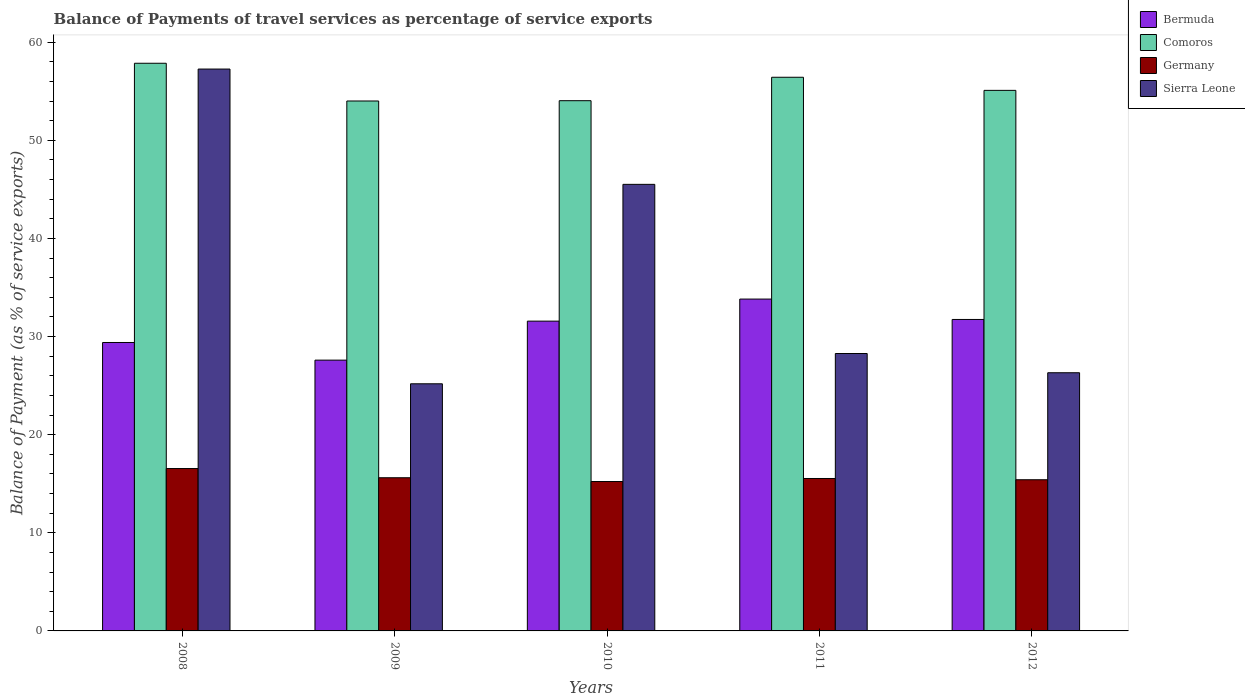How many different coloured bars are there?
Ensure brevity in your answer.  4. How many bars are there on the 3rd tick from the left?
Provide a succinct answer. 4. How many bars are there on the 3rd tick from the right?
Provide a succinct answer. 4. What is the balance of payments of travel services in Sierra Leone in 2012?
Ensure brevity in your answer.  26.31. Across all years, what is the maximum balance of payments of travel services in Germany?
Make the answer very short. 16.55. Across all years, what is the minimum balance of payments of travel services in Germany?
Keep it short and to the point. 15.23. In which year was the balance of payments of travel services in Bermuda maximum?
Provide a short and direct response. 2011. What is the total balance of payments of travel services in Bermuda in the graph?
Provide a succinct answer. 154.12. What is the difference between the balance of payments of travel services in Comoros in 2010 and that in 2012?
Your answer should be very brief. -1.05. What is the difference between the balance of payments of travel services in Comoros in 2010 and the balance of payments of travel services in Sierra Leone in 2012?
Your answer should be compact. 27.73. What is the average balance of payments of travel services in Germany per year?
Your answer should be very brief. 15.67. In the year 2011, what is the difference between the balance of payments of travel services in Comoros and balance of payments of travel services in Bermuda?
Give a very brief answer. 22.61. What is the ratio of the balance of payments of travel services in Germany in 2009 to that in 2010?
Offer a terse response. 1.03. What is the difference between the highest and the second highest balance of payments of travel services in Bermuda?
Offer a terse response. 2.08. What is the difference between the highest and the lowest balance of payments of travel services in Comoros?
Make the answer very short. 3.85. Is the sum of the balance of payments of travel services in Germany in 2008 and 2010 greater than the maximum balance of payments of travel services in Comoros across all years?
Offer a very short reply. No. What does the 3rd bar from the left in 2009 represents?
Keep it short and to the point. Germany. What does the 1st bar from the right in 2012 represents?
Your answer should be compact. Sierra Leone. Is it the case that in every year, the sum of the balance of payments of travel services in Bermuda and balance of payments of travel services in Sierra Leone is greater than the balance of payments of travel services in Comoros?
Offer a terse response. No. How many bars are there?
Offer a very short reply. 20. Are all the bars in the graph horizontal?
Keep it short and to the point. No. What is the difference between two consecutive major ticks on the Y-axis?
Make the answer very short. 10. Are the values on the major ticks of Y-axis written in scientific E-notation?
Make the answer very short. No. Where does the legend appear in the graph?
Provide a short and direct response. Top right. What is the title of the graph?
Provide a succinct answer. Balance of Payments of travel services as percentage of service exports. Does "Lao PDR" appear as one of the legend labels in the graph?
Ensure brevity in your answer.  No. What is the label or title of the X-axis?
Make the answer very short. Years. What is the label or title of the Y-axis?
Your response must be concise. Balance of Payment (as % of service exports). What is the Balance of Payment (as % of service exports) of Bermuda in 2008?
Your answer should be very brief. 29.39. What is the Balance of Payment (as % of service exports) in Comoros in 2008?
Ensure brevity in your answer.  57.85. What is the Balance of Payment (as % of service exports) in Germany in 2008?
Offer a very short reply. 16.55. What is the Balance of Payment (as % of service exports) of Sierra Leone in 2008?
Your response must be concise. 57.26. What is the Balance of Payment (as % of service exports) of Bermuda in 2009?
Your response must be concise. 27.6. What is the Balance of Payment (as % of service exports) of Comoros in 2009?
Your response must be concise. 54.01. What is the Balance of Payment (as % of service exports) in Germany in 2009?
Your answer should be very brief. 15.61. What is the Balance of Payment (as % of service exports) of Sierra Leone in 2009?
Make the answer very short. 25.19. What is the Balance of Payment (as % of service exports) of Bermuda in 2010?
Make the answer very short. 31.57. What is the Balance of Payment (as % of service exports) in Comoros in 2010?
Provide a short and direct response. 54.04. What is the Balance of Payment (as % of service exports) in Germany in 2010?
Your response must be concise. 15.23. What is the Balance of Payment (as % of service exports) in Sierra Leone in 2010?
Offer a terse response. 45.51. What is the Balance of Payment (as % of service exports) of Bermuda in 2011?
Keep it short and to the point. 33.82. What is the Balance of Payment (as % of service exports) of Comoros in 2011?
Ensure brevity in your answer.  56.42. What is the Balance of Payment (as % of service exports) of Germany in 2011?
Provide a short and direct response. 15.53. What is the Balance of Payment (as % of service exports) in Sierra Leone in 2011?
Your answer should be very brief. 28.27. What is the Balance of Payment (as % of service exports) in Bermuda in 2012?
Your answer should be compact. 31.74. What is the Balance of Payment (as % of service exports) in Comoros in 2012?
Make the answer very short. 55.09. What is the Balance of Payment (as % of service exports) of Germany in 2012?
Keep it short and to the point. 15.41. What is the Balance of Payment (as % of service exports) in Sierra Leone in 2012?
Ensure brevity in your answer.  26.31. Across all years, what is the maximum Balance of Payment (as % of service exports) of Bermuda?
Your answer should be very brief. 33.82. Across all years, what is the maximum Balance of Payment (as % of service exports) in Comoros?
Keep it short and to the point. 57.85. Across all years, what is the maximum Balance of Payment (as % of service exports) in Germany?
Give a very brief answer. 16.55. Across all years, what is the maximum Balance of Payment (as % of service exports) of Sierra Leone?
Offer a very short reply. 57.26. Across all years, what is the minimum Balance of Payment (as % of service exports) in Bermuda?
Keep it short and to the point. 27.6. Across all years, what is the minimum Balance of Payment (as % of service exports) in Comoros?
Keep it short and to the point. 54.01. Across all years, what is the minimum Balance of Payment (as % of service exports) of Germany?
Your response must be concise. 15.23. Across all years, what is the minimum Balance of Payment (as % of service exports) of Sierra Leone?
Your response must be concise. 25.19. What is the total Balance of Payment (as % of service exports) of Bermuda in the graph?
Your response must be concise. 154.12. What is the total Balance of Payment (as % of service exports) of Comoros in the graph?
Keep it short and to the point. 277.41. What is the total Balance of Payment (as % of service exports) in Germany in the graph?
Offer a terse response. 78.33. What is the total Balance of Payment (as % of service exports) in Sierra Leone in the graph?
Keep it short and to the point. 182.54. What is the difference between the Balance of Payment (as % of service exports) of Bermuda in 2008 and that in 2009?
Make the answer very short. 1.8. What is the difference between the Balance of Payment (as % of service exports) in Comoros in 2008 and that in 2009?
Your response must be concise. 3.85. What is the difference between the Balance of Payment (as % of service exports) of Germany in 2008 and that in 2009?
Your answer should be compact. 0.94. What is the difference between the Balance of Payment (as % of service exports) in Sierra Leone in 2008 and that in 2009?
Ensure brevity in your answer.  32.08. What is the difference between the Balance of Payment (as % of service exports) in Bermuda in 2008 and that in 2010?
Keep it short and to the point. -2.18. What is the difference between the Balance of Payment (as % of service exports) in Comoros in 2008 and that in 2010?
Your response must be concise. 3.81. What is the difference between the Balance of Payment (as % of service exports) in Germany in 2008 and that in 2010?
Your answer should be compact. 1.32. What is the difference between the Balance of Payment (as % of service exports) in Sierra Leone in 2008 and that in 2010?
Keep it short and to the point. 11.75. What is the difference between the Balance of Payment (as % of service exports) in Bermuda in 2008 and that in 2011?
Offer a terse response. -4.43. What is the difference between the Balance of Payment (as % of service exports) of Comoros in 2008 and that in 2011?
Provide a succinct answer. 1.43. What is the difference between the Balance of Payment (as % of service exports) in Germany in 2008 and that in 2011?
Give a very brief answer. 1.01. What is the difference between the Balance of Payment (as % of service exports) of Sierra Leone in 2008 and that in 2011?
Give a very brief answer. 28.99. What is the difference between the Balance of Payment (as % of service exports) of Bermuda in 2008 and that in 2012?
Ensure brevity in your answer.  -2.35. What is the difference between the Balance of Payment (as % of service exports) in Comoros in 2008 and that in 2012?
Your answer should be very brief. 2.76. What is the difference between the Balance of Payment (as % of service exports) of Germany in 2008 and that in 2012?
Your answer should be compact. 1.14. What is the difference between the Balance of Payment (as % of service exports) in Sierra Leone in 2008 and that in 2012?
Keep it short and to the point. 30.95. What is the difference between the Balance of Payment (as % of service exports) in Bermuda in 2009 and that in 2010?
Provide a succinct answer. -3.97. What is the difference between the Balance of Payment (as % of service exports) of Comoros in 2009 and that in 2010?
Give a very brief answer. -0.03. What is the difference between the Balance of Payment (as % of service exports) of Germany in 2009 and that in 2010?
Your answer should be compact. 0.38. What is the difference between the Balance of Payment (as % of service exports) in Sierra Leone in 2009 and that in 2010?
Provide a short and direct response. -20.33. What is the difference between the Balance of Payment (as % of service exports) of Bermuda in 2009 and that in 2011?
Offer a terse response. -6.22. What is the difference between the Balance of Payment (as % of service exports) in Comoros in 2009 and that in 2011?
Keep it short and to the point. -2.42. What is the difference between the Balance of Payment (as % of service exports) in Germany in 2009 and that in 2011?
Ensure brevity in your answer.  0.08. What is the difference between the Balance of Payment (as % of service exports) of Sierra Leone in 2009 and that in 2011?
Provide a short and direct response. -3.09. What is the difference between the Balance of Payment (as % of service exports) in Bermuda in 2009 and that in 2012?
Keep it short and to the point. -4.14. What is the difference between the Balance of Payment (as % of service exports) of Comoros in 2009 and that in 2012?
Offer a terse response. -1.08. What is the difference between the Balance of Payment (as % of service exports) of Germany in 2009 and that in 2012?
Your answer should be very brief. 0.2. What is the difference between the Balance of Payment (as % of service exports) of Sierra Leone in 2009 and that in 2012?
Provide a short and direct response. -1.13. What is the difference between the Balance of Payment (as % of service exports) in Bermuda in 2010 and that in 2011?
Make the answer very short. -2.25. What is the difference between the Balance of Payment (as % of service exports) in Comoros in 2010 and that in 2011?
Give a very brief answer. -2.39. What is the difference between the Balance of Payment (as % of service exports) of Germany in 2010 and that in 2011?
Your response must be concise. -0.31. What is the difference between the Balance of Payment (as % of service exports) of Sierra Leone in 2010 and that in 2011?
Your response must be concise. 17.24. What is the difference between the Balance of Payment (as % of service exports) in Bermuda in 2010 and that in 2012?
Offer a very short reply. -0.17. What is the difference between the Balance of Payment (as % of service exports) of Comoros in 2010 and that in 2012?
Your response must be concise. -1.05. What is the difference between the Balance of Payment (as % of service exports) of Germany in 2010 and that in 2012?
Provide a succinct answer. -0.18. What is the difference between the Balance of Payment (as % of service exports) in Sierra Leone in 2010 and that in 2012?
Your answer should be compact. 19.2. What is the difference between the Balance of Payment (as % of service exports) in Bermuda in 2011 and that in 2012?
Your answer should be compact. 2.08. What is the difference between the Balance of Payment (as % of service exports) of Comoros in 2011 and that in 2012?
Provide a short and direct response. 1.34. What is the difference between the Balance of Payment (as % of service exports) in Germany in 2011 and that in 2012?
Your response must be concise. 0.13. What is the difference between the Balance of Payment (as % of service exports) in Sierra Leone in 2011 and that in 2012?
Keep it short and to the point. 1.96. What is the difference between the Balance of Payment (as % of service exports) in Bermuda in 2008 and the Balance of Payment (as % of service exports) in Comoros in 2009?
Your response must be concise. -24.61. What is the difference between the Balance of Payment (as % of service exports) in Bermuda in 2008 and the Balance of Payment (as % of service exports) in Germany in 2009?
Your response must be concise. 13.78. What is the difference between the Balance of Payment (as % of service exports) in Bermuda in 2008 and the Balance of Payment (as % of service exports) in Sierra Leone in 2009?
Your response must be concise. 4.21. What is the difference between the Balance of Payment (as % of service exports) of Comoros in 2008 and the Balance of Payment (as % of service exports) of Germany in 2009?
Provide a short and direct response. 42.24. What is the difference between the Balance of Payment (as % of service exports) of Comoros in 2008 and the Balance of Payment (as % of service exports) of Sierra Leone in 2009?
Your answer should be very brief. 32.67. What is the difference between the Balance of Payment (as % of service exports) in Germany in 2008 and the Balance of Payment (as % of service exports) in Sierra Leone in 2009?
Provide a succinct answer. -8.64. What is the difference between the Balance of Payment (as % of service exports) in Bermuda in 2008 and the Balance of Payment (as % of service exports) in Comoros in 2010?
Your answer should be very brief. -24.64. What is the difference between the Balance of Payment (as % of service exports) of Bermuda in 2008 and the Balance of Payment (as % of service exports) of Germany in 2010?
Give a very brief answer. 14.17. What is the difference between the Balance of Payment (as % of service exports) in Bermuda in 2008 and the Balance of Payment (as % of service exports) in Sierra Leone in 2010?
Give a very brief answer. -16.12. What is the difference between the Balance of Payment (as % of service exports) in Comoros in 2008 and the Balance of Payment (as % of service exports) in Germany in 2010?
Offer a very short reply. 42.63. What is the difference between the Balance of Payment (as % of service exports) in Comoros in 2008 and the Balance of Payment (as % of service exports) in Sierra Leone in 2010?
Provide a short and direct response. 12.34. What is the difference between the Balance of Payment (as % of service exports) in Germany in 2008 and the Balance of Payment (as % of service exports) in Sierra Leone in 2010?
Offer a very short reply. -28.96. What is the difference between the Balance of Payment (as % of service exports) of Bermuda in 2008 and the Balance of Payment (as % of service exports) of Comoros in 2011?
Keep it short and to the point. -27.03. What is the difference between the Balance of Payment (as % of service exports) of Bermuda in 2008 and the Balance of Payment (as % of service exports) of Germany in 2011?
Provide a succinct answer. 13.86. What is the difference between the Balance of Payment (as % of service exports) of Bermuda in 2008 and the Balance of Payment (as % of service exports) of Sierra Leone in 2011?
Your answer should be compact. 1.12. What is the difference between the Balance of Payment (as % of service exports) of Comoros in 2008 and the Balance of Payment (as % of service exports) of Germany in 2011?
Ensure brevity in your answer.  42.32. What is the difference between the Balance of Payment (as % of service exports) of Comoros in 2008 and the Balance of Payment (as % of service exports) of Sierra Leone in 2011?
Provide a succinct answer. 29.58. What is the difference between the Balance of Payment (as % of service exports) of Germany in 2008 and the Balance of Payment (as % of service exports) of Sierra Leone in 2011?
Keep it short and to the point. -11.72. What is the difference between the Balance of Payment (as % of service exports) in Bermuda in 2008 and the Balance of Payment (as % of service exports) in Comoros in 2012?
Offer a very short reply. -25.69. What is the difference between the Balance of Payment (as % of service exports) in Bermuda in 2008 and the Balance of Payment (as % of service exports) in Germany in 2012?
Your response must be concise. 13.99. What is the difference between the Balance of Payment (as % of service exports) of Bermuda in 2008 and the Balance of Payment (as % of service exports) of Sierra Leone in 2012?
Keep it short and to the point. 3.08. What is the difference between the Balance of Payment (as % of service exports) of Comoros in 2008 and the Balance of Payment (as % of service exports) of Germany in 2012?
Offer a terse response. 42.44. What is the difference between the Balance of Payment (as % of service exports) of Comoros in 2008 and the Balance of Payment (as % of service exports) of Sierra Leone in 2012?
Provide a succinct answer. 31.54. What is the difference between the Balance of Payment (as % of service exports) in Germany in 2008 and the Balance of Payment (as % of service exports) in Sierra Leone in 2012?
Make the answer very short. -9.76. What is the difference between the Balance of Payment (as % of service exports) in Bermuda in 2009 and the Balance of Payment (as % of service exports) in Comoros in 2010?
Your answer should be very brief. -26.44. What is the difference between the Balance of Payment (as % of service exports) of Bermuda in 2009 and the Balance of Payment (as % of service exports) of Germany in 2010?
Offer a terse response. 12.37. What is the difference between the Balance of Payment (as % of service exports) of Bermuda in 2009 and the Balance of Payment (as % of service exports) of Sierra Leone in 2010?
Provide a succinct answer. -17.91. What is the difference between the Balance of Payment (as % of service exports) of Comoros in 2009 and the Balance of Payment (as % of service exports) of Germany in 2010?
Your answer should be compact. 38.78. What is the difference between the Balance of Payment (as % of service exports) of Comoros in 2009 and the Balance of Payment (as % of service exports) of Sierra Leone in 2010?
Your response must be concise. 8.5. What is the difference between the Balance of Payment (as % of service exports) in Germany in 2009 and the Balance of Payment (as % of service exports) in Sierra Leone in 2010?
Give a very brief answer. -29.9. What is the difference between the Balance of Payment (as % of service exports) of Bermuda in 2009 and the Balance of Payment (as % of service exports) of Comoros in 2011?
Your answer should be very brief. -28.83. What is the difference between the Balance of Payment (as % of service exports) of Bermuda in 2009 and the Balance of Payment (as % of service exports) of Germany in 2011?
Provide a succinct answer. 12.06. What is the difference between the Balance of Payment (as % of service exports) in Bermuda in 2009 and the Balance of Payment (as % of service exports) in Sierra Leone in 2011?
Your answer should be compact. -0.67. What is the difference between the Balance of Payment (as % of service exports) of Comoros in 2009 and the Balance of Payment (as % of service exports) of Germany in 2011?
Your answer should be compact. 38.47. What is the difference between the Balance of Payment (as % of service exports) in Comoros in 2009 and the Balance of Payment (as % of service exports) in Sierra Leone in 2011?
Your response must be concise. 25.74. What is the difference between the Balance of Payment (as % of service exports) of Germany in 2009 and the Balance of Payment (as % of service exports) of Sierra Leone in 2011?
Make the answer very short. -12.66. What is the difference between the Balance of Payment (as % of service exports) in Bermuda in 2009 and the Balance of Payment (as % of service exports) in Comoros in 2012?
Offer a terse response. -27.49. What is the difference between the Balance of Payment (as % of service exports) of Bermuda in 2009 and the Balance of Payment (as % of service exports) of Germany in 2012?
Provide a short and direct response. 12.19. What is the difference between the Balance of Payment (as % of service exports) in Bermuda in 2009 and the Balance of Payment (as % of service exports) in Sierra Leone in 2012?
Make the answer very short. 1.29. What is the difference between the Balance of Payment (as % of service exports) in Comoros in 2009 and the Balance of Payment (as % of service exports) in Germany in 2012?
Your answer should be very brief. 38.6. What is the difference between the Balance of Payment (as % of service exports) in Comoros in 2009 and the Balance of Payment (as % of service exports) in Sierra Leone in 2012?
Offer a terse response. 27.7. What is the difference between the Balance of Payment (as % of service exports) of Germany in 2009 and the Balance of Payment (as % of service exports) of Sierra Leone in 2012?
Keep it short and to the point. -10.7. What is the difference between the Balance of Payment (as % of service exports) of Bermuda in 2010 and the Balance of Payment (as % of service exports) of Comoros in 2011?
Ensure brevity in your answer.  -24.85. What is the difference between the Balance of Payment (as % of service exports) of Bermuda in 2010 and the Balance of Payment (as % of service exports) of Germany in 2011?
Provide a succinct answer. 16.04. What is the difference between the Balance of Payment (as % of service exports) in Bermuda in 2010 and the Balance of Payment (as % of service exports) in Sierra Leone in 2011?
Your answer should be compact. 3.3. What is the difference between the Balance of Payment (as % of service exports) of Comoros in 2010 and the Balance of Payment (as % of service exports) of Germany in 2011?
Your answer should be compact. 38.5. What is the difference between the Balance of Payment (as % of service exports) of Comoros in 2010 and the Balance of Payment (as % of service exports) of Sierra Leone in 2011?
Ensure brevity in your answer.  25.77. What is the difference between the Balance of Payment (as % of service exports) of Germany in 2010 and the Balance of Payment (as % of service exports) of Sierra Leone in 2011?
Your answer should be compact. -13.05. What is the difference between the Balance of Payment (as % of service exports) of Bermuda in 2010 and the Balance of Payment (as % of service exports) of Comoros in 2012?
Offer a very short reply. -23.52. What is the difference between the Balance of Payment (as % of service exports) in Bermuda in 2010 and the Balance of Payment (as % of service exports) in Germany in 2012?
Offer a terse response. 16.16. What is the difference between the Balance of Payment (as % of service exports) of Bermuda in 2010 and the Balance of Payment (as % of service exports) of Sierra Leone in 2012?
Provide a succinct answer. 5.26. What is the difference between the Balance of Payment (as % of service exports) in Comoros in 2010 and the Balance of Payment (as % of service exports) in Germany in 2012?
Your answer should be compact. 38.63. What is the difference between the Balance of Payment (as % of service exports) in Comoros in 2010 and the Balance of Payment (as % of service exports) in Sierra Leone in 2012?
Offer a very short reply. 27.73. What is the difference between the Balance of Payment (as % of service exports) of Germany in 2010 and the Balance of Payment (as % of service exports) of Sierra Leone in 2012?
Offer a very short reply. -11.09. What is the difference between the Balance of Payment (as % of service exports) in Bermuda in 2011 and the Balance of Payment (as % of service exports) in Comoros in 2012?
Give a very brief answer. -21.27. What is the difference between the Balance of Payment (as % of service exports) of Bermuda in 2011 and the Balance of Payment (as % of service exports) of Germany in 2012?
Make the answer very short. 18.41. What is the difference between the Balance of Payment (as % of service exports) of Bermuda in 2011 and the Balance of Payment (as % of service exports) of Sierra Leone in 2012?
Make the answer very short. 7.51. What is the difference between the Balance of Payment (as % of service exports) of Comoros in 2011 and the Balance of Payment (as % of service exports) of Germany in 2012?
Offer a terse response. 41.02. What is the difference between the Balance of Payment (as % of service exports) in Comoros in 2011 and the Balance of Payment (as % of service exports) in Sierra Leone in 2012?
Your answer should be very brief. 30.11. What is the difference between the Balance of Payment (as % of service exports) in Germany in 2011 and the Balance of Payment (as % of service exports) in Sierra Leone in 2012?
Keep it short and to the point. -10.78. What is the average Balance of Payment (as % of service exports) of Bermuda per year?
Give a very brief answer. 30.82. What is the average Balance of Payment (as % of service exports) in Comoros per year?
Your answer should be very brief. 55.48. What is the average Balance of Payment (as % of service exports) of Germany per year?
Keep it short and to the point. 15.67. What is the average Balance of Payment (as % of service exports) in Sierra Leone per year?
Give a very brief answer. 36.51. In the year 2008, what is the difference between the Balance of Payment (as % of service exports) of Bermuda and Balance of Payment (as % of service exports) of Comoros?
Make the answer very short. -28.46. In the year 2008, what is the difference between the Balance of Payment (as % of service exports) of Bermuda and Balance of Payment (as % of service exports) of Germany?
Offer a terse response. 12.84. In the year 2008, what is the difference between the Balance of Payment (as % of service exports) of Bermuda and Balance of Payment (as % of service exports) of Sierra Leone?
Make the answer very short. -27.87. In the year 2008, what is the difference between the Balance of Payment (as % of service exports) of Comoros and Balance of Payment (as % of service exports) of Germany?
Your answer should be very brief. 41.3. In the year 2008, what is the difference between the Balance of Payment (as % of service exports) of Comoros and Balance of Payment (as % of service exports) of Sierra Leone?
Offer a very short reply. 0.59. In the year 2008, what is the difference between the Balance of Payment (as % of service exports) of Germany and Balance of Payment (as % of service exports) of Sierra Leone?
Provide a succinct answer. -40.71. In the year 2009, what is the difference between the Balance of Payment (as % of service exports) in Bermuda and Balance of Payment (as % of service exports) in Comoros?
Provide a succinct answer. -26.41. In the year 2009, what is the difference between the Balance of Payment (as % of service exports) of Bermuda and Balance of Payment (as % of service exports) of Germany?
Provide a succinct answer. 11.99. In the year 2009, what is the difference between the Balance of Payment (as % of service exports) in Bermuda and Balance of Payment (as % of service exports) in Sierra Leone?
Ensure brevity in your answer.  2.41. In the year 2009, what is the difference between the Balance of Payment (as % of service exports) of Comoros and Balance of Payment (as % of service exports) of Germany?
Give a very brief answer. 38.4. In the year 2009, what is the difference between the Balance of Payment (as % of service exports) of Comoros and Balance of Payment (as % of service exports) of Sierra Leone?
Your answer should be very brief. 28.82. In the year 2009, what is the difference between the Balance of Payment (as % of service exports) of Germany and Balance of Payment (as % of service exports) of Sierra Leone?
Offer a terse response. -9.58. In the year 2010, what is the difference between the Balance of Payment (as % of service exports) in Bermuda and Balance of Payment (as % of service exports) in Comoros?
Offer a very short reply. -22.47. In the year 2010, what is the difference between the Balance of Payment (as % of service exports) of Bermuda and Balance of Payment (as % of service exports) of Germany?
Your answer should be compact. 16.35. In the year 2010, what is the difference between the Balance of Payment (as % of service exports) of Bermuda and Balance of Payment (as % of service exports) of Sierra Leone?
Provide a succinct answer. -13.94. In the year 2010, what is the difference between the Balance of Payment (as % of service exports) in Comoros and Balance of Payment (as % of service exports) in Germany?
Your answer should be very brief. 38.81. In the year 2010, what is the difference between the Balance of Payment (as % of service exports) in Comoros and Balance of Payment (as % of service exports) in Sierra Leone?
Your answer should be very brief. 8.53. In the year 2010, what is the difference between the Balance of Payment (as % of service exports) in Germany and Balance of Payment (as % of service exports) in Sierra Leone?
Your answer should be compact. -30.29. In the year 2011, what is the difference between the Balance of Payment (as % of service exports) of Bermuda and Balance of Payment (as % of service exports) of Comoros?
Provide a short and direct response. -22.61. In the year 2011, what is the difference between the Balance of Payment (as % of service exports) in Bermuda and Balance of Payment (as % of service exports) in Germany?
Give a very brief answer. 18.29. In the year 2011, what is the difference between the Balance of Payment (as % of service exports) in Bermuda and Balance of Payment (as % of service exports) in Sierra Leone?
Offer a very short reply. 5.55. In the year 2011, what is the difference between the Balance of Payment (as % of service exports) in Comoros and Balance of Payment (as % of service exports) in Germany?
Offer a terse response. 40.89. In the year 2011, what is the difference between the Balance of Payment (as % of service exports) of Comoros and Balance of Payment (as % of service exports) of Sierra Leone?
Keep it short and to the point. 28.15. In the year 2011, what is the difference between the Balance of Payment (as % of service exports) in Germany and Balance of Payment (as % of service exports) in Sierra Leone?
Your answer should be very brief. -12.74. In the year 2012, what is the difference between the Balance of Payment (as % of service exports) in Bermuda and Balance of Payment (as % of service exports) in Comoros?
Your answer should be compact. -23.35. In the year 2012, what is the difference between the Balance of Payment (as % of service exports) in Bermuda and Balance of Payment (as % of service exports) in Germany?
Keep it short and to the point. 16.33. In the year 2012, what is the difference between the Balance of Payment (as % of service exports) of Bermuda and Balance of Payment (as % of service exports) of Sierra Leone?
Your answer should be very brief. 5.43. In the year 2012, what is the difference between the Balance of Payment (as % of service exports) in Comoros and Balance of Payment (as % of service exports) in Germany?
Your answer should be very brief. 39.68. In the year 2012, what is the difference between the Balance of Payment (as % of service exports) in Comoros and Balance of Payment (as % of service exports) in Sierra Leone?
Give a very brief answer. 28.78. In the year 2012, what is the difference between the Balance of Payment (as % of service exports) of Germany and Balance of Payment (as % of service exports) of Sierra Leone?
Provide a succinct answer. -10.9. What is the ratio of the Balance of Payment (as % of service exports) of Bermuda in 2008 to that in 2009?
Give a very brief answer. 1.07. What is the ratio of the Balance of Payment (as % of service exports) in Comoros in 2008 to that in 2009?
Keep it short and to the point. 1.07. What is the ratio of the Balance of Payment (as % of service exports) in Germany in 2008 to that in 2009?
Give a very brief answer. 1.06. What is the ratio of the Balance of Payment (as % of service exports) in Sierra Leone in 2008 to that in 2009?
Give a very brief answer. 2.27. What is the ratio of the Balance of Payment (as % of service exports) in Comoros in 2008 to that in 2010?
Make the answer very short. 1.07. What is the ratio of the Balance of Payment (as % of service exports) of Germany in 2008 to that in 2010?
Keep it short and to the point. 1.09. What is the ratio of the Balance of Payment (as % of service exports) of Sierra Leone in 2008 to that in 2010?
Give a very brief answer. 1.26. What is the ratio of the Balance of Payment (as % of service exports) of Bermuda in 2008 to that in 2011?
Keep it short and to the point. 0.87. What is the ratio of the Balance of Payment (as % of service exports) in Comoros in 2008 to that in 2011?
Keep it short and to the point. 1.03. What is the ratio of the Balance of Payment (as % of service exports) of Germany in 2008 to that in 2011?
Make the answer very short. 1.07. What is the ratio of the Balance of Payment (as % of service exports) of Sierra Leone in 2008 to that in 2011?
Make the answer very short. 2.03. What is the ratio of the Balance of Payment (as % of service exports) in Bermuda in 2008 to that in 2012?
Keep it short and to the point. 0.93. What is the ratio of the Balance of Payment (as % of service exports) in Comoros in 2008 to that in 2012?
Offer a very short reply. 1.05. What is the ratio of the Balance of Payment (as % of service exports) in Germany in 2008 to that in 2012?
Offer a very short reply. 1.07. What is the ratio of the Balance of Payment (as % of service exports) in Sierra Leone in 2008 to that in 2012?
Ensure brevity in your answer.  2.18. What is the ratio of the Balance of Payment (as % of service exports) in Bermuda in 2009 to that in 2010?
Offer a terse response. 0.87. What is the ratio of the Balance of Payment (as % of service exports) of Germany in 2009 to that in 2010?
Make the answer very short. 1.03. What is the ratio of the Balance of Payment (as % of service exports) in Sierra Leone in 2009 to that in 2010?
Offer a terse response. 0.55. What is the ratio of the Balance of Payment (as % of service exports) in Bermuda in 2009 to that in 2011?
Your answer should be very brief. 0.82. What is the ratio of the Balance of Payment (as % of service exports) in Comoros in 2009 to that in 2011?
Offer a very short reply. 0.96. What is the ratio of the Balance of Payment (as % of service exports) in Germany in 2009 to that in 2011?
Your response must be concise. 1. What is the ratio of the Balance of Payment (as % of service exports) of Sierra Leone in 2009 to that in 2011?
Keep it short and to the point. 0.89. What is the ratio of the Balance of Payment (as % of service exports) of Bermuda in 2009 to that in 2012?
Offer a very short reply. 0.87. What is the ratio of the Balance of Payment (as % of service exports) of Comoros in 2009 to that in 2012?
Your answer should be very brief. 0.98. What is the ratio of the Balance of Payment (as % of service exports) of Germany in 2009 to that in 2012?
Your response must be concise. 1.01. What is the ratio of the Balance of Payment (as % of service exports) in Sierra Leone in 2009 to that in 2012?
Keep it short and to the point. 0.96. What is the ratio of the Balance of Payment (as % of service exports) of Bermuda in 2010 to that in 2011?
Offer a terse response. 0.93. What is the ratio of the Balance of Payment (as % of service exports) of Comoros in 2010 to that in 2011?
Ensure brevity in your answer.  0.96. What is the ratio of the Balance of Payment (as % of service exports) in Germany in 2010 to that in 2011?
Make the answer very short. 0.98. What is the ratio of the Balance of Payment (as % of service exports) of Sierra Leone in 2010 to that in 2011?
Offer a terse response. 1.61. What is the ratio of the Balance of Payment (as % of service exports) of Bermuda in 2010 to that in 2012?
Provide a short and direct response. 0.99. What is the ratio of the Balance of Payment (as % of service exports) of Comoros in 2010 to that in 2012?
Keep it short and to the point. 0.98. What is the ratio of the Balance of Payment (as % of service exports) of Sierra Leone in 2010 to that in 2012?
Provide a succinct answer. 1.73. What is the ratio of the Balance of Payment (as % of service exports) of Bermuda in 2011 to that in 2012?
Give a very brief answer. 1.07. What is the ratio of the Balance of Payment (as % of service exports) in Comoros in 2011 to that in 2012?
Ensure brevity in your answer.  1.02. What is the ratio of the Balance of Payment (as % of service exports) in Germany in 2011 to that in 2012?
Offer a terse response. 1.01. What is the ratio of the Balance of Payment (as % of service exports) of Sierra Leone in 2011 to that in 2012?
Provide a short and direct response. 1.07. What is the difference between the highest and the second highest Balance of Payment (as % of service exports) in Bermuda?
Give a very brief answer. 2.08. What is the difference between the highest and the second highest Balance of Payment (as % of service exports) in Comoros?
Ensure brevity in your answer.  1.43. What is the difference between the highest and the second highest Balance of Payment (as % of service exports) of Germany?
Offer a terse response. 0.94. What is the difference between the highest and the second highest Balance of Payment (as % of service exports) in Sierra Leone?
Make the answer very short. 11.75. What is the difference between the highest and the lowest Balance of Payment (as % of service exports) in Bermuda?
Make the answer very short. 6.22. What is the difference between the highest and the lowest Balance of Payment (as % of service exports) of Comoros?
Your answer should be compact. 3.85. What is the difference between the highest and the lowest Balance of Payment (as % of service exports) of Germany?
Your answer should be compact. 1.32. What is the difference between the highest and the lowest Balance of Payment (as % of service exports) in Sierra Leone?
Make the answer very short. 32.08. 